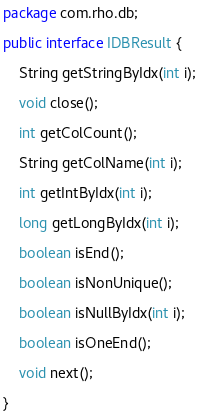<code> <loc_0><loc_0><loc_500><loc_500><_Java_>package com.rho.db;

public interface IDBResult {

	String getStringByIdx(int i);

	void close();

	int getColCount();

	String getColName(int i);

	int getIntByIdx(int i);

	long getLongByIdx(int i);

	boolean isEnd();

	boolean isNonUnique();

	boolean isNullByIdx(int i);

	boolean isOneEnd();

	void next();

}
</code> 